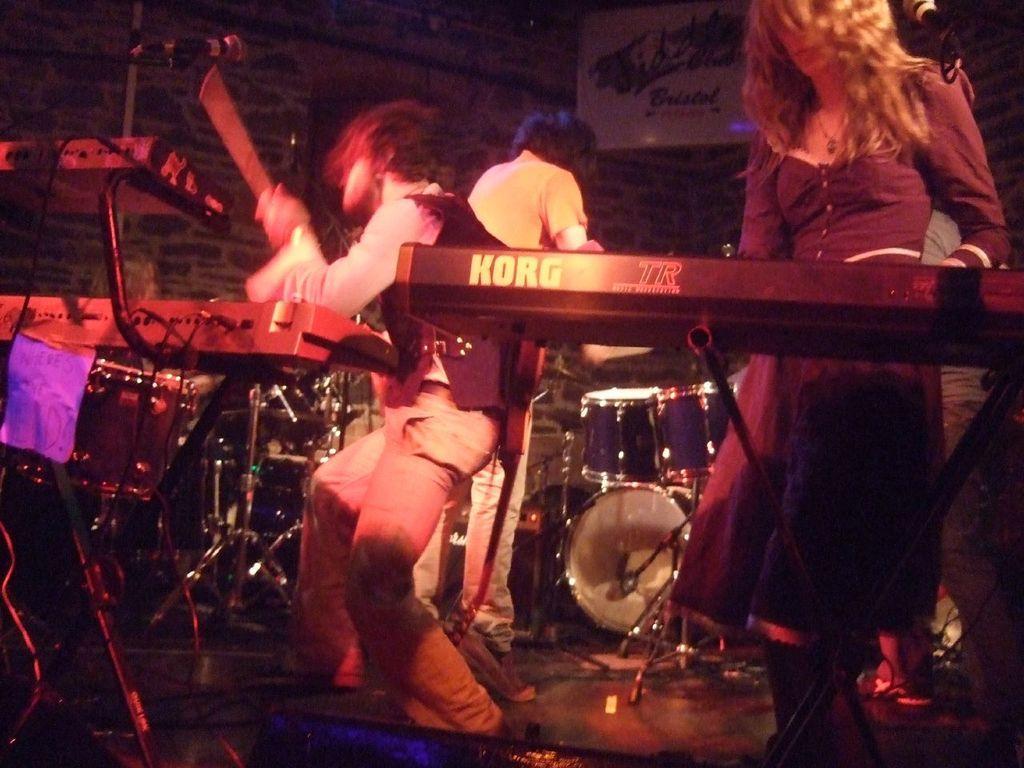Please provide a concise description of this image. In this image there are people playing musical instruments, in the background there is a wall. 